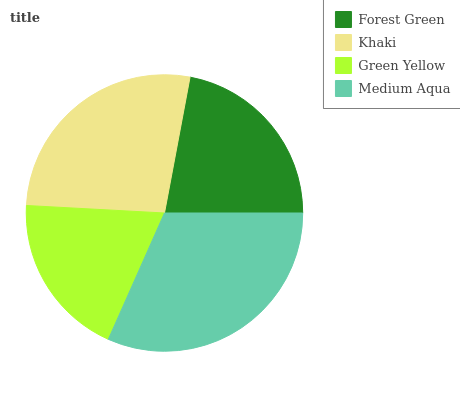Is Green Yellow the minimum?
Answer yes or no. Yes. Is Medium Aqua the maximum?
Answer yes or no. Yes. Is Khaki the minimum?
Answer yes or no. No. Is Khaki the maximum?
Answer yes or no. No. Is Khaki greater than Forest Green?
Answer yes or no. Yes. Is Forest Green less than Khaki?
Answer yes or no. Yes. Is Forest Green greater than Khaki?
Answer yes or no. No. Is Khaki less than Forest Green?
Answer yes or no. No. Is Khaki the high median?
Answer yes or no. Yes. Is Forest Green the low median?
Answer yes or no. Yes. Is Medium Aqua the high median?
Answer yes or no. No. Is Green Yellow the low median?
Answer yes or no. No. 